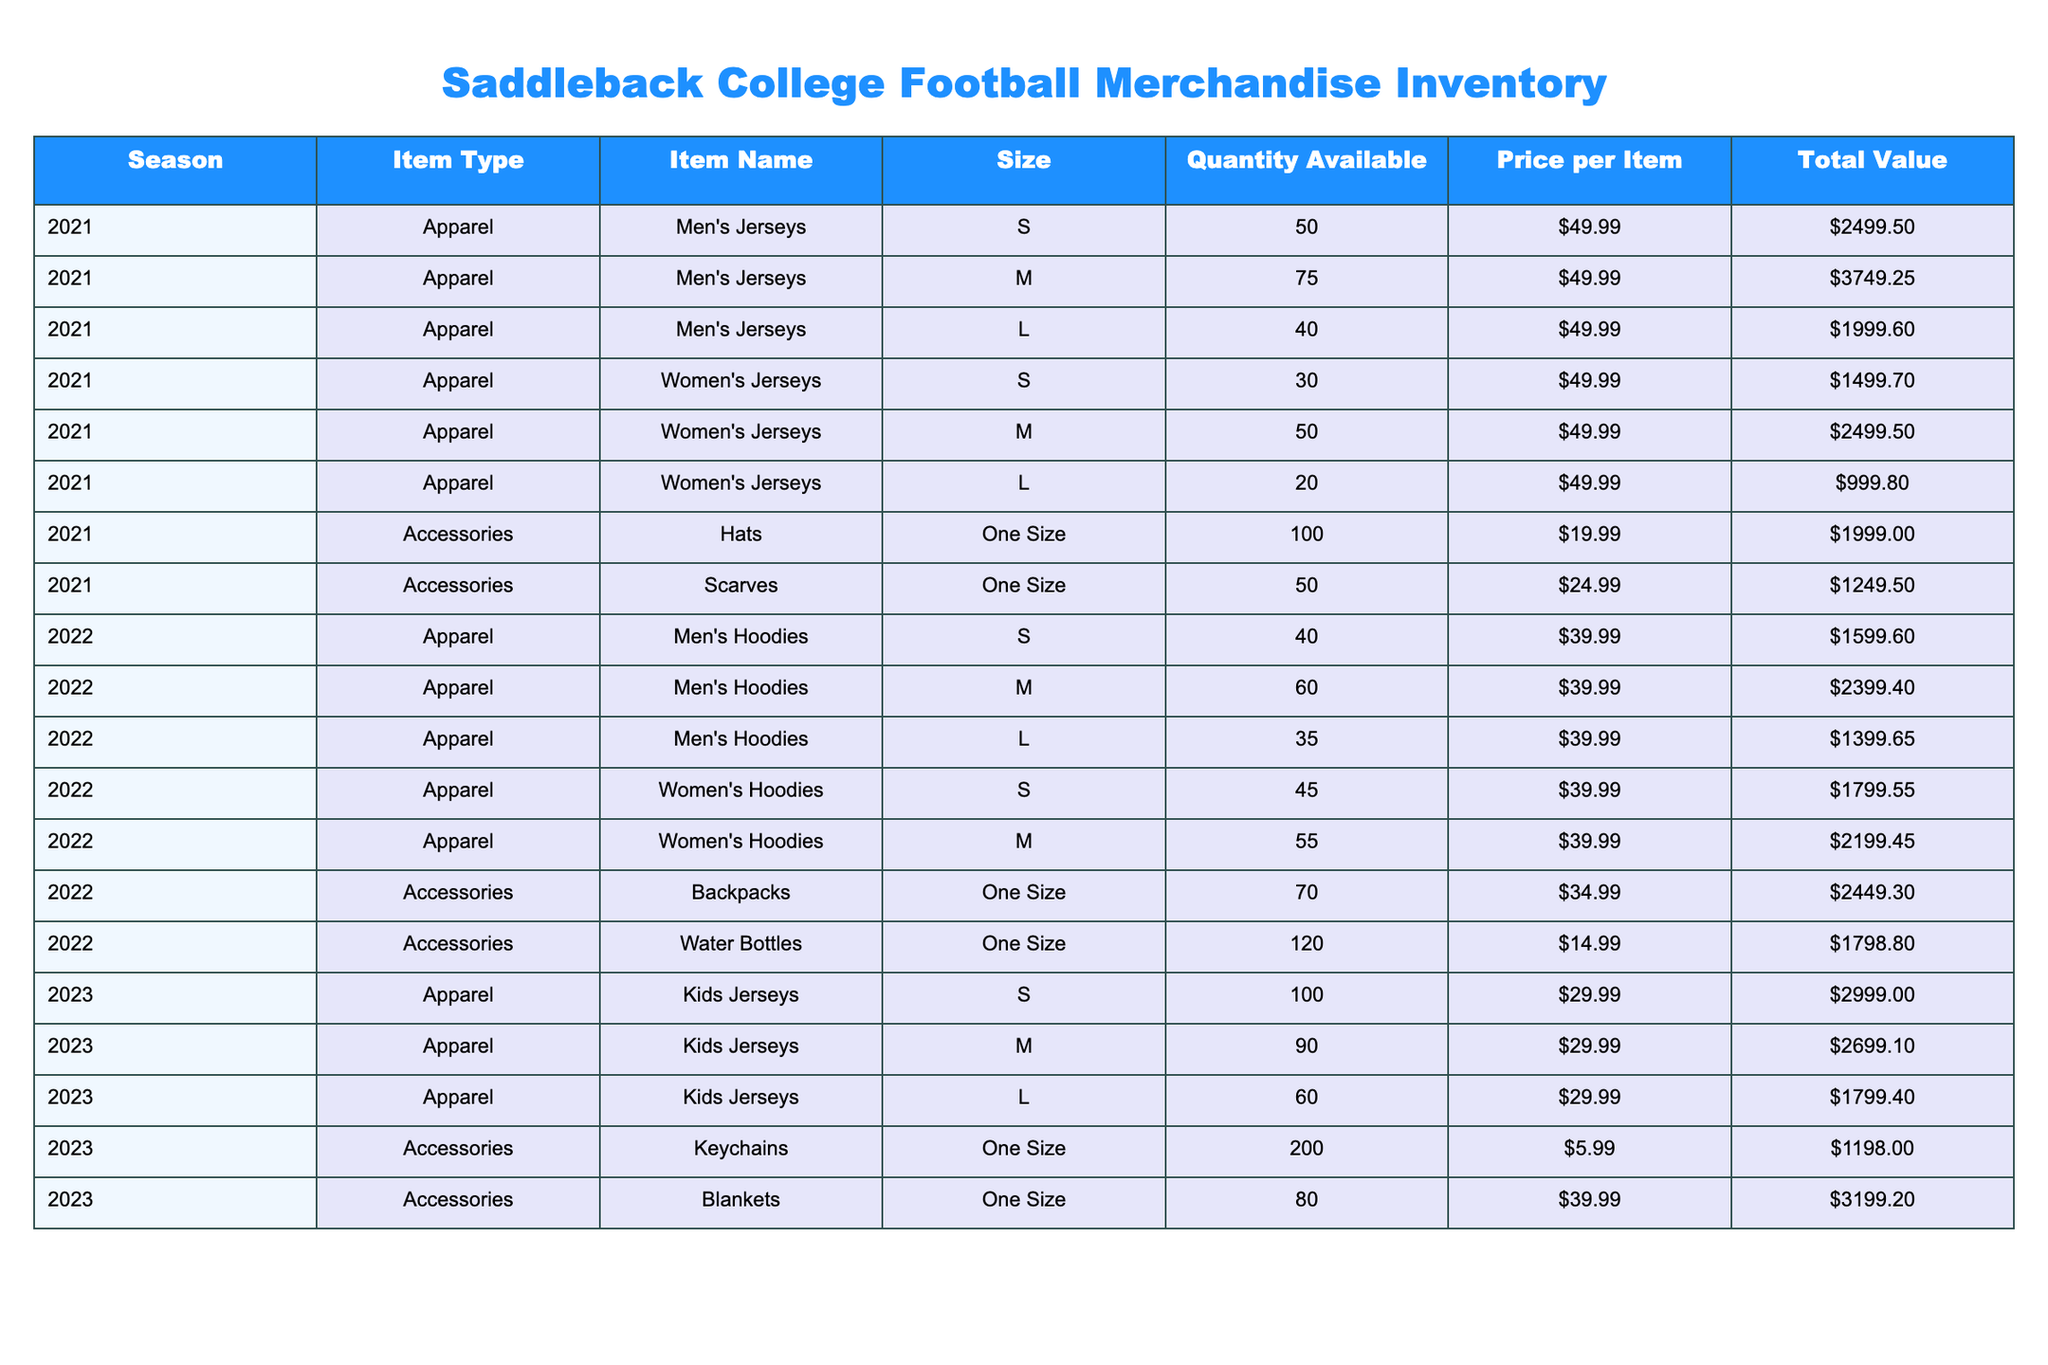What is the total quantity of Men's Jerseys available for the 2021 season? To find the total quantity, we need to add the quantities of all sizes for Men's Jerseys in the 2021 season: 50 (S) + 75 (M) + 40 (L) = 165.
Answer: 165 What is the total value of Women's Hoodies available for the 2022 season? The total value for Women's Hoodies can be calculated by adding the total values of each size: 1799.55 (S) + 2199.45 (M) = 3999.00.
Answer: 3999.00 Are there more than 150 Hats available in the 2021 inventory? There are 100 Hats available for the 2021 season, which is not more than 150.
Answer: No What is the average price of Kids Jerseys for the 2023 season? The price per Kids Jersey is the same across sizes: 29.99 for all sizes. Therefore, the average price is also 29.99.
Answer: 29.99 What is the total value of all merchandise for the 2021 season? To find this, we sum the total values of all items in the 2021 season: 2499.50 (Men's Jerseys) + 3749.25 (Men's Jerseys) + 1999.60 (Men's Jerseys) + 1499.70 (Women's Jerseys) + 2499.50 (Women's Jerseys) + 999.80 (Women's Jerseys) + 1999.00 (Hats) + 1249.50 (Scarves) = 12244.75.
Answer: 12244.75 What items have a total value greater than 2000 for the 2022 season? We need to check the total value of each item for the 2022 season: Men's Hoodies (all sizes) total 5398.65 and Backpacks total 2449.30, which are both greater than 2000. Water Bottles have a value of 1798.80, which does not exceed 2000. Thus, the qualifying items are Men's Hoodies and Backpacks.
Answer: Men's Hoodies, Backpacks 